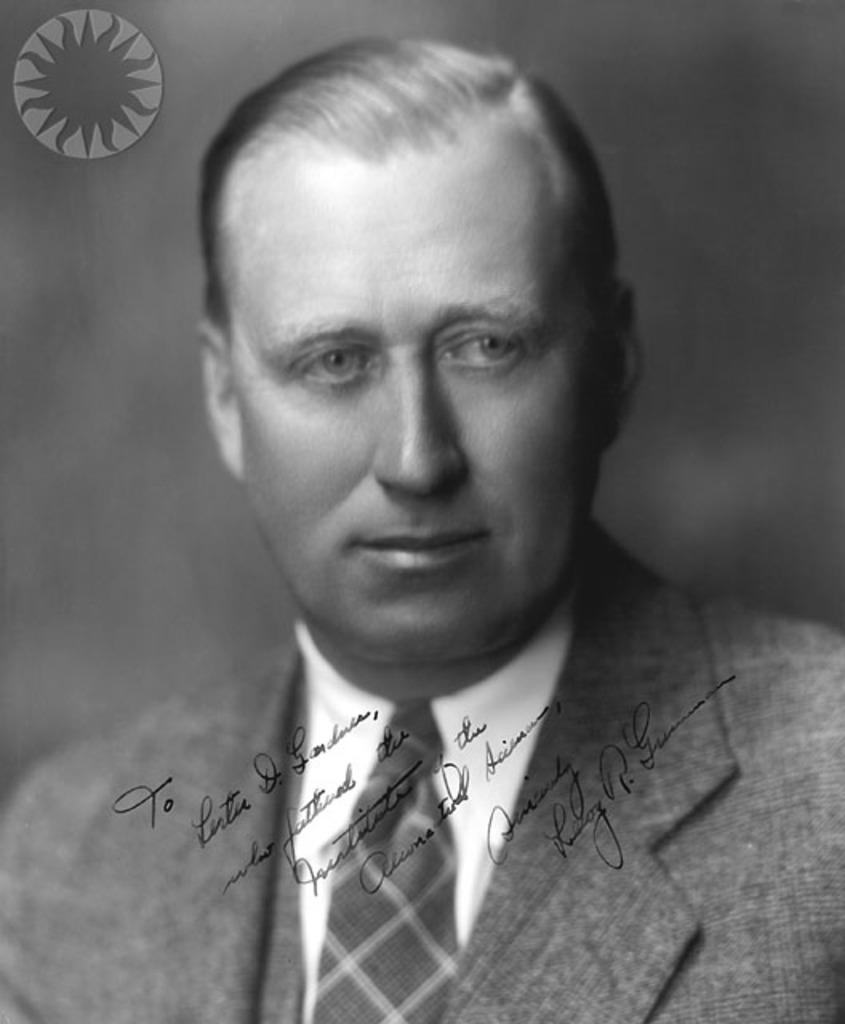Who or what is the main subject in the center of the image? There is a person in the center of the image. What can be seen in addition to the person in the image? There is something written in the image. Can you describe any additional elements in the image? There is a watermark in the top left corner of the image. What type of plastic material can be seen in the image? There is no plastic material present in the image. What scent is associated with the person in the image? The image does not provide any information about the scent of the person. 